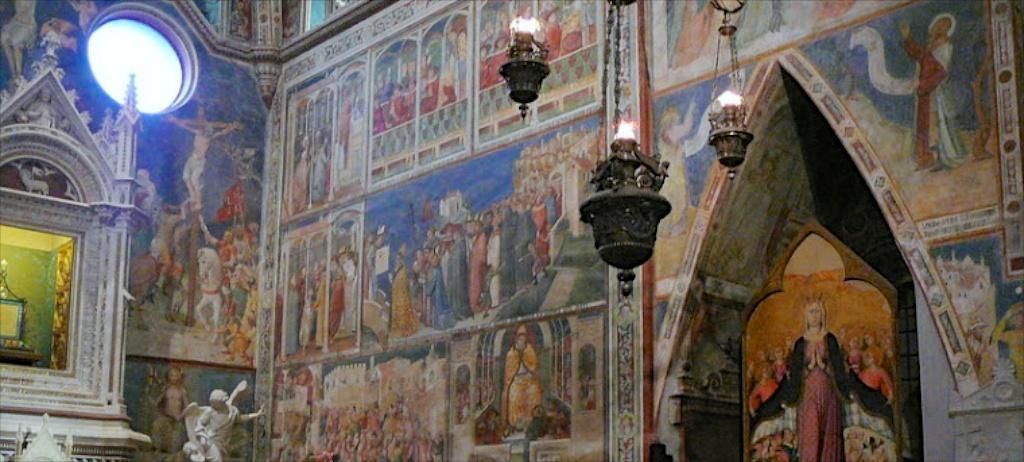Can you describe this image briefly? In this picture we can see an object, statue, lanterns, paintings on the walls and some objects. 